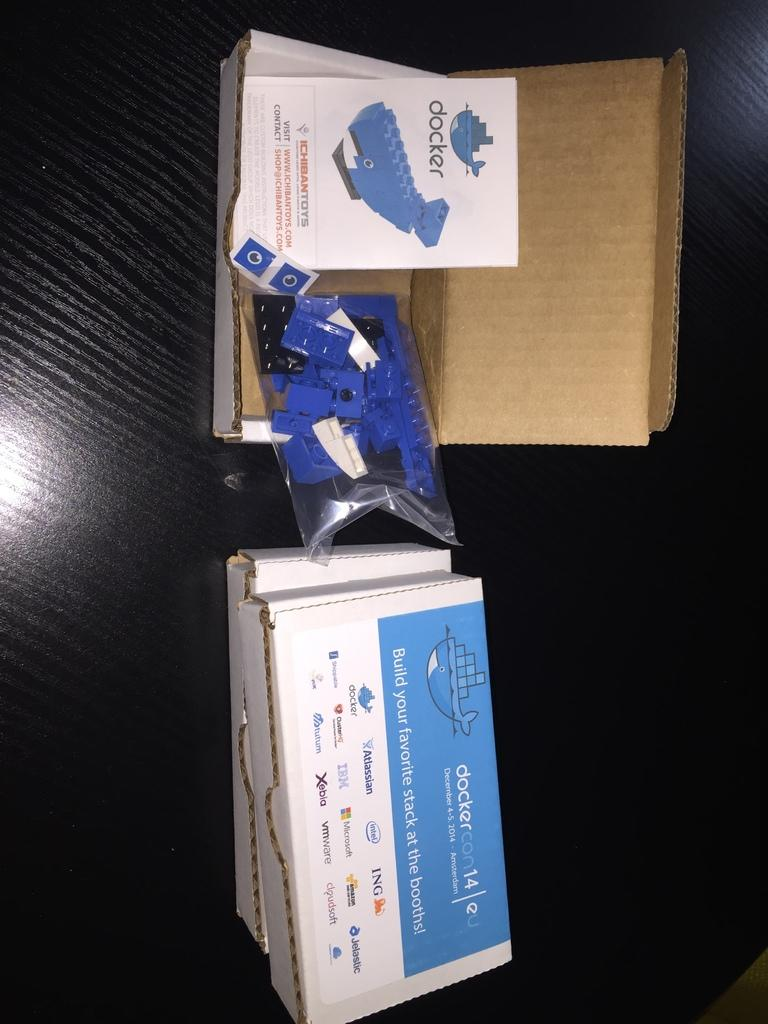<image>
Render a clear and concise summary of the photo. an open package of Docker building bricks for a whale in a box 